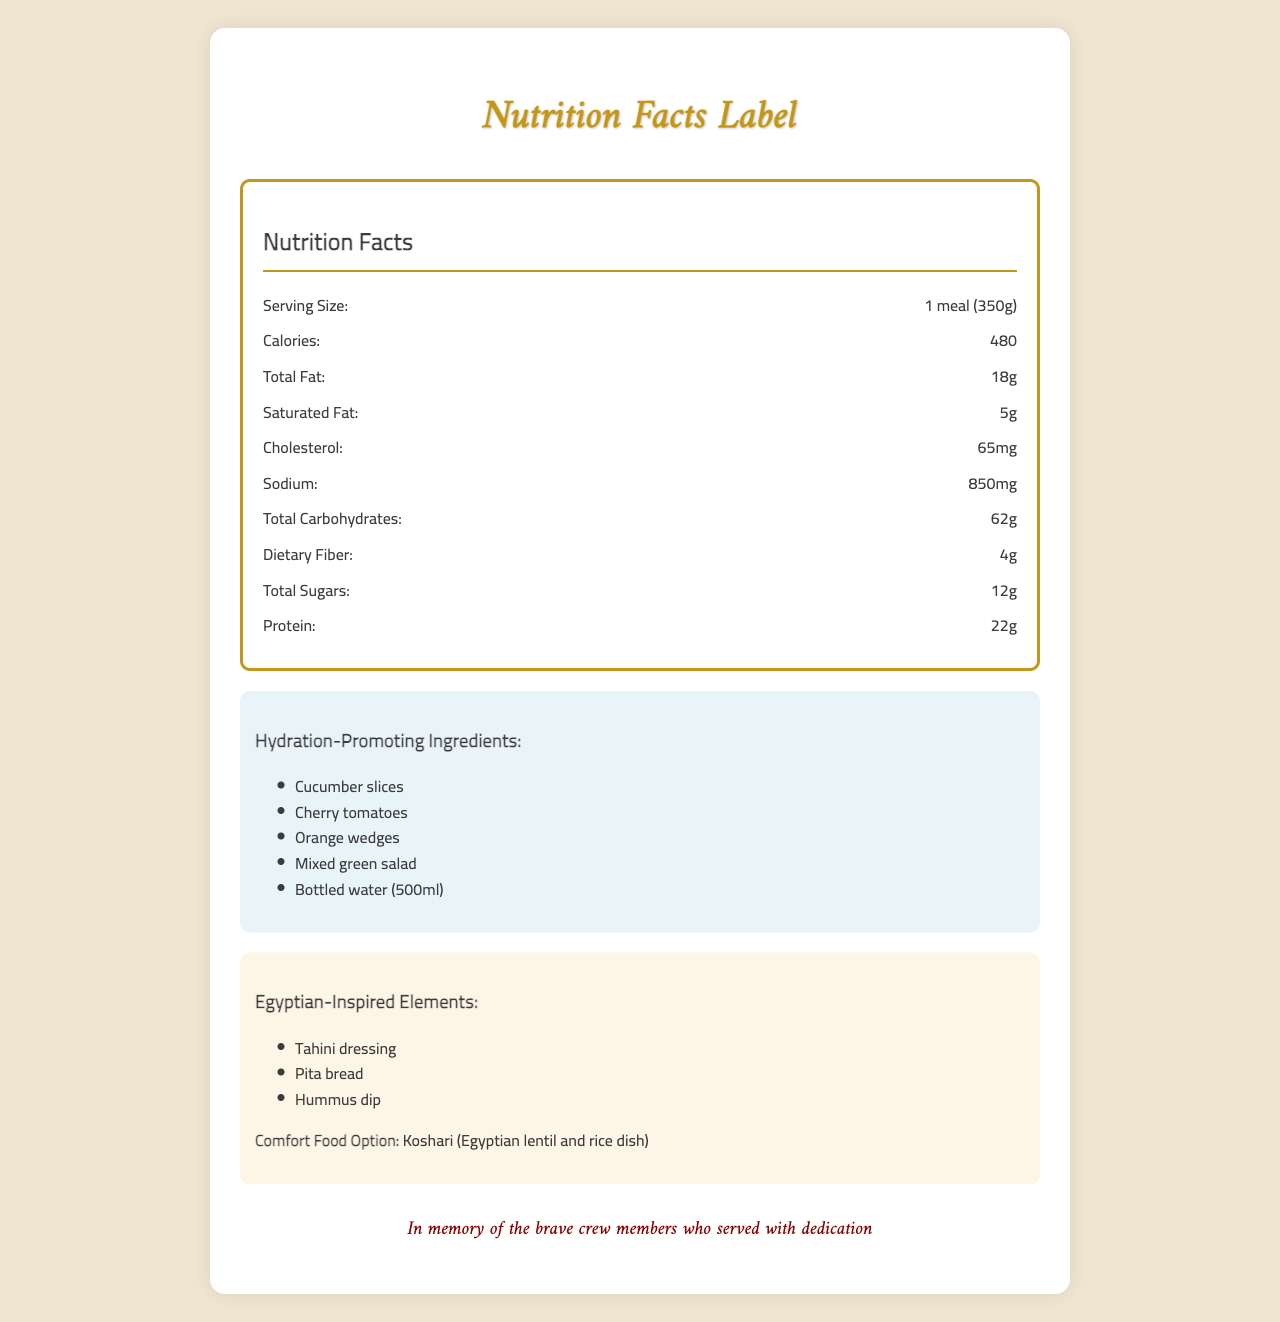How much sodium is in the airline meal? The nutrition facts section lists the sodium content as 850mg.
Answer: 850mg What are some hydration-promoting ingredients included in the meal? The hydration-promoting ingredients section lists these items.
Answer: Cucumber slices, Cherry tomatoes, Orange wedges, Mixed green salad, Bottled water (500ml) How much dietary fiber is in the meal? The nutrition facts section lists the dietary fiber content as 4g.
Answer: 4g What is the serving size of the meal? The nutrition facts section lists the serving size as "1 meal (350g)".
Answer: 1 meal (350g) Is a low-sodium option available? The document contains a special note stating that a low-sodium option is available upon request.
Answer: Yes What is the main dish of the meal? The main dish is listed as grilled chicken with rice pilaf in the meal description.
Answer: Grilled chicken with rice pilaf Which of the following is NOT listed as a hydration-promoting ingredient? A. Orange wedges B. Dark chocolate C. Cucumber slices D. Mixed green salad Dark chocolate is not listed among the hydration-promoting ingredients.
Answer: B Which nutrient is provided in the highest percentage relative to daily value? A. Vitamin A B. Vitamin C C. Calcium D. Iron The meal provides 25% of daily value for vitamin C, which is the highest among the listed nutrients.
Answer: B Does the meal contain any allergens? The document states that the meal contains wheat, milk, and soy.
Answer: Yes Describe the main focus of the Nutrition Facts Label document. The document includes detailed information on the nutrient content, hydration ingredients, cultural elements, and a memorial note, all presented within the context of the meal offered on the flight.
Answer: The document provides the nutritional content of an airline meal, highlights hydration-promoting ingredients, features Egyptian-inspired elements, and includes a memorial message for crew members. How many grams of trans fat are in the meal? The nutrition facts section lists the trans fat content as 0g.
Answer: 0g Can I find out the specific vitamin percentages for vitamin A and vitamin C from this document? The percentages for vitamin A and vitamin C are listed as 15% and 25% of the daily value, respectively.
Answer: Yes What hydration-promoting ingredients are specifically part of the side dish? The document lists hydration-promoting ingredients generally but does not specify which ones are part of the side dish.
Answer: Not enough information 